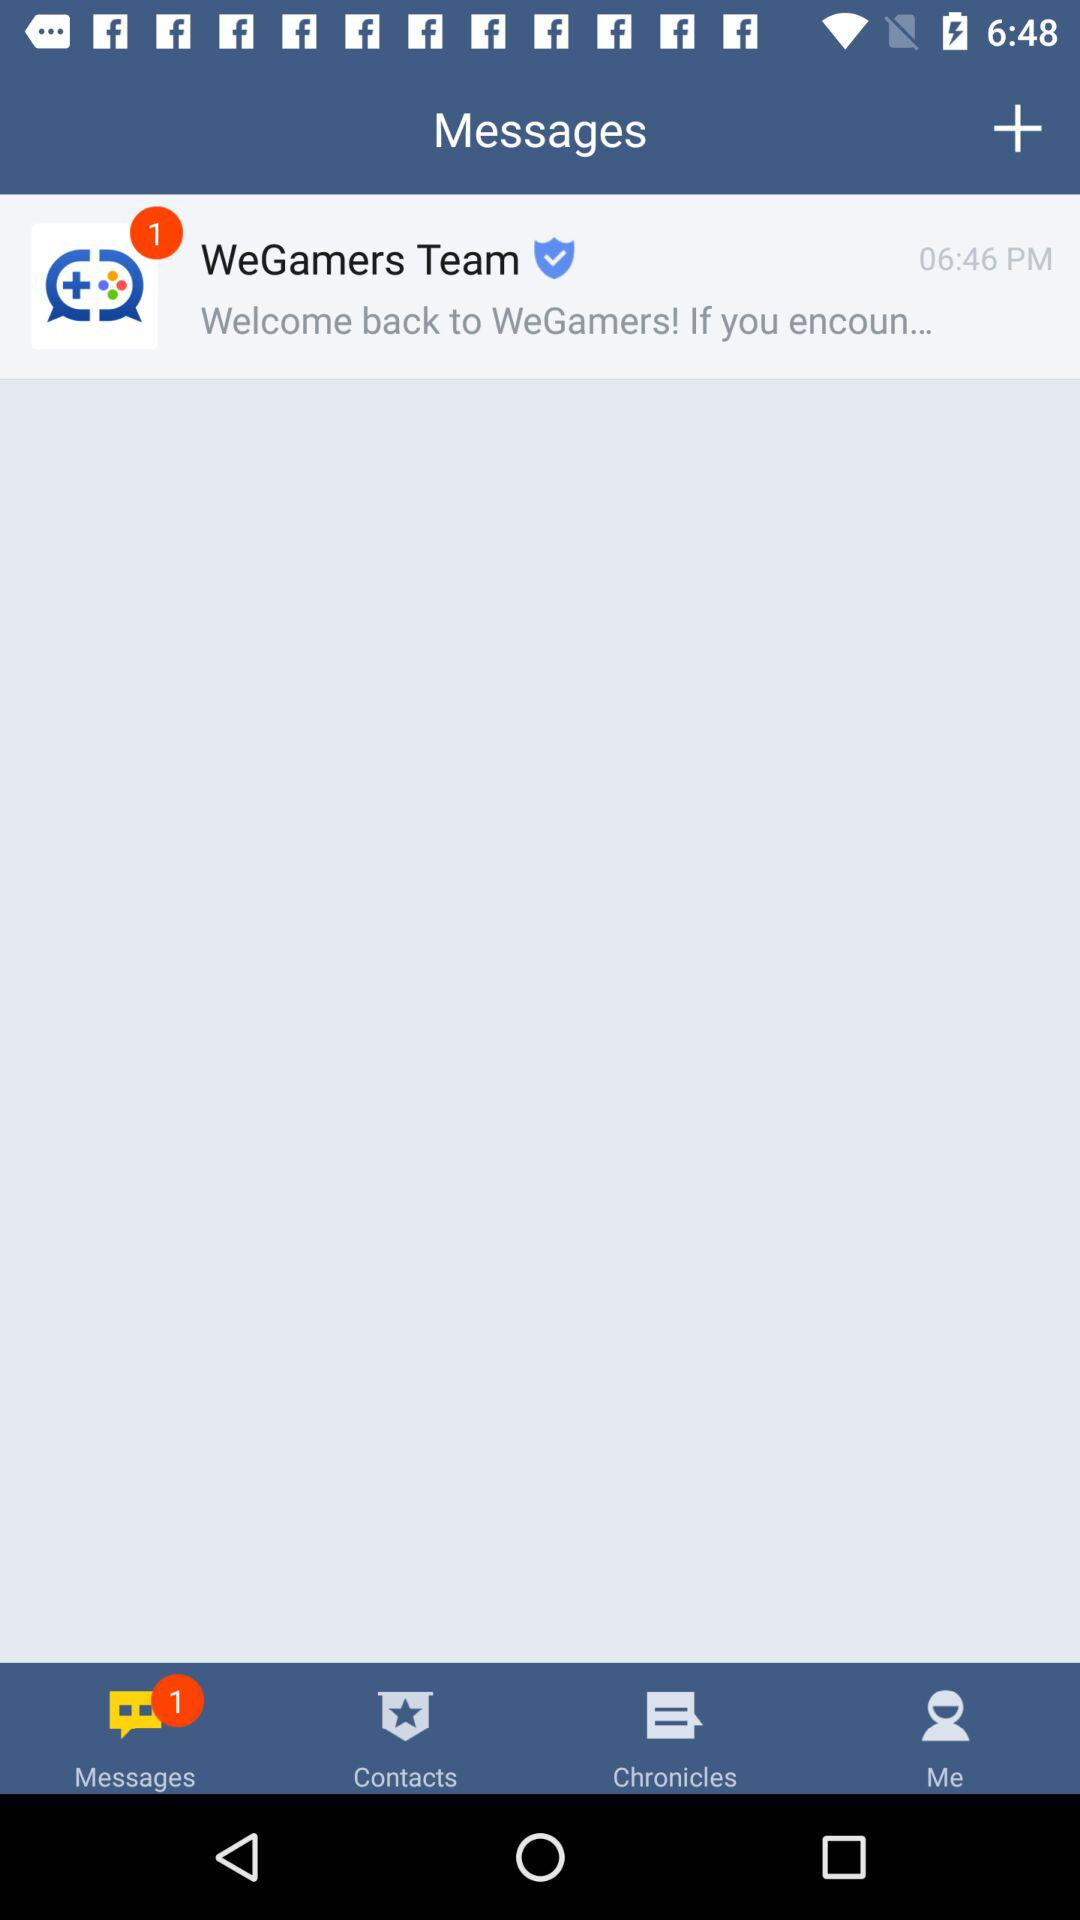How many notifications on messages are there? There is 1 notification on messages. 